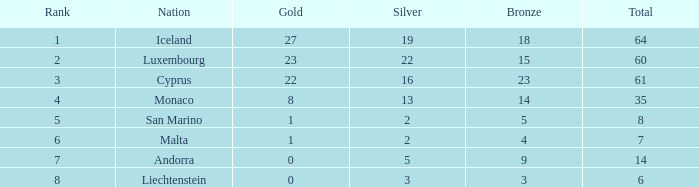Where does Iceland rank with under 19 silvers? None. 